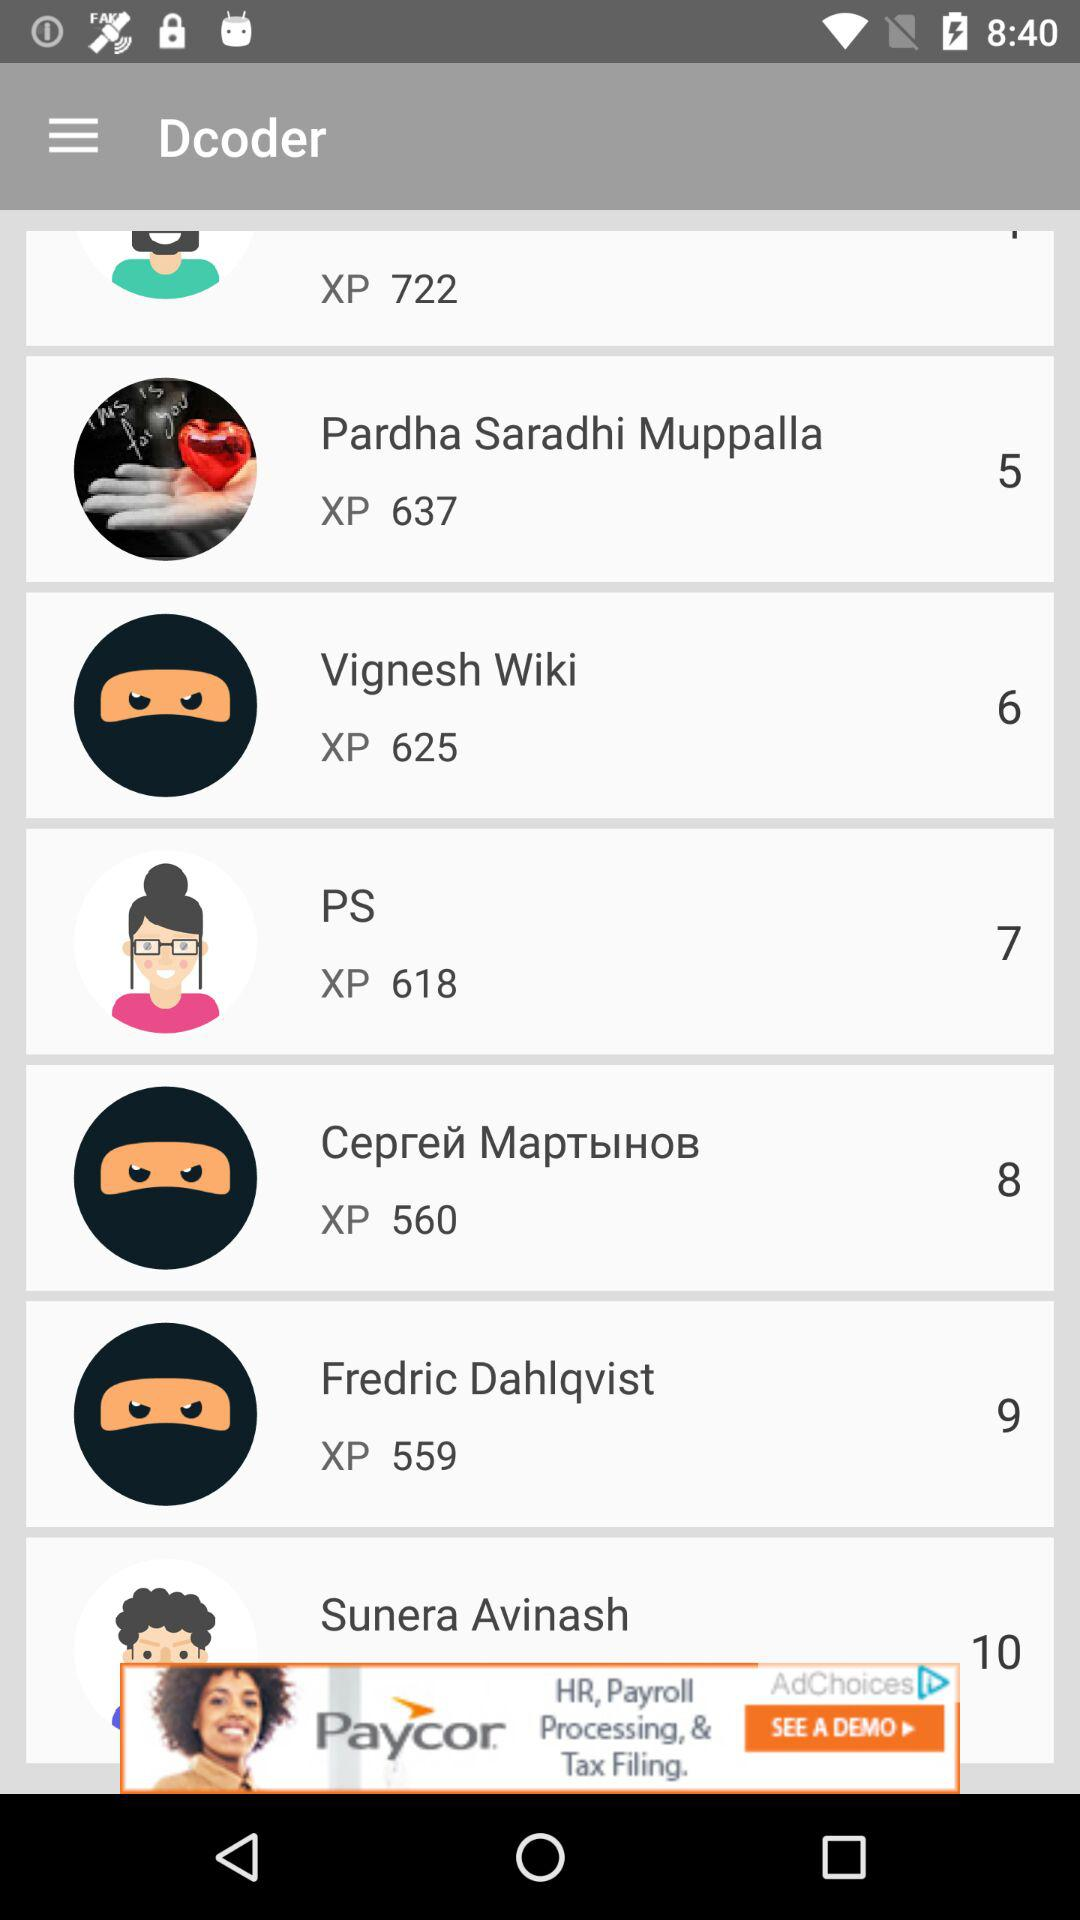How many points does Sunera Avinash have? Sunera Avinash has 10 points. 